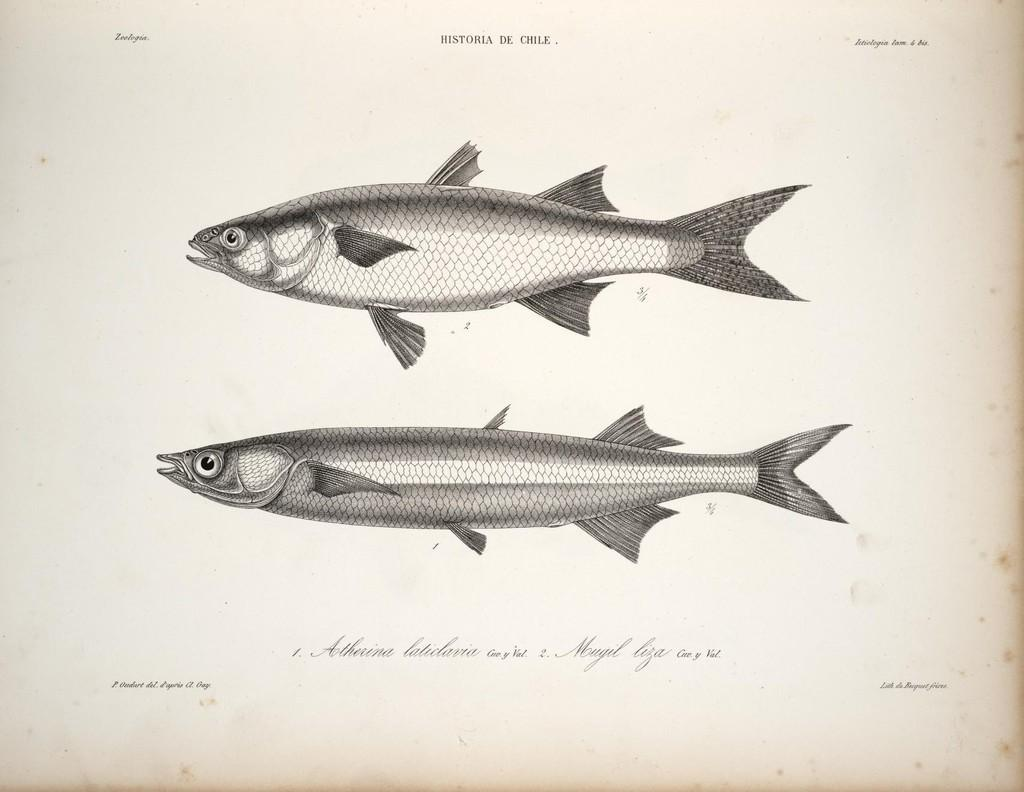What animals are present in the image? There are two fish in the image. What else can be seen in the image besides the fish? There is text visible on a page in the image. Who is the owner of the fish in the image? There is no information about the ownership of the fish in the image. What type of milk is being used in the image? There is no milk present in the image. 